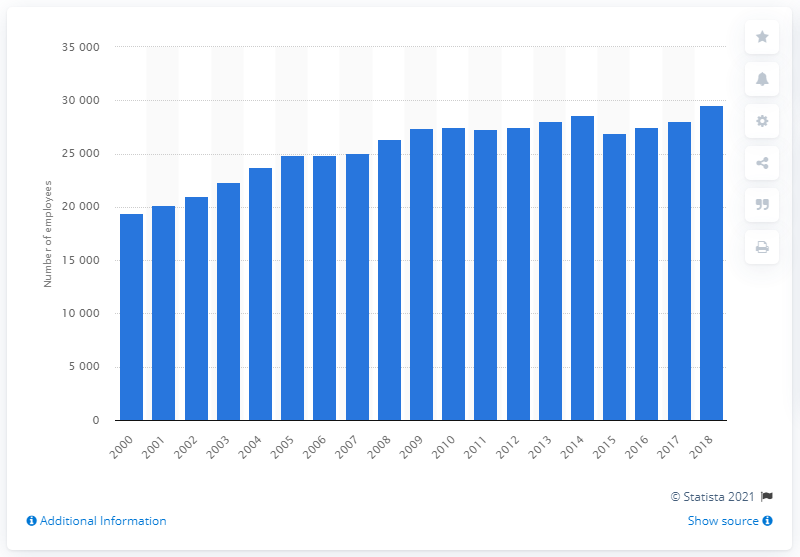Highlight a few significant elements in this photo. In 2018, there were approximately 29,563 physiotherapists employed in the United Kingdom. In 2000, a total of 19,417 physiotherapists were employed in the United Kingdom. 